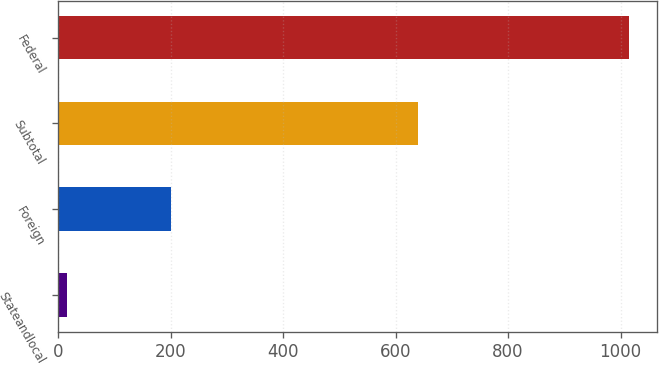Convert chart. <chart><loc_0><loc_0><loc_500><loc_500><bar_chart><fcel>Stateandlocal<fcel>Foreign<fcel>Subtotal<fcel>Federal<nl><fcel>15<fcel>200<fcel>639<fcel>1015<nl></chart> 